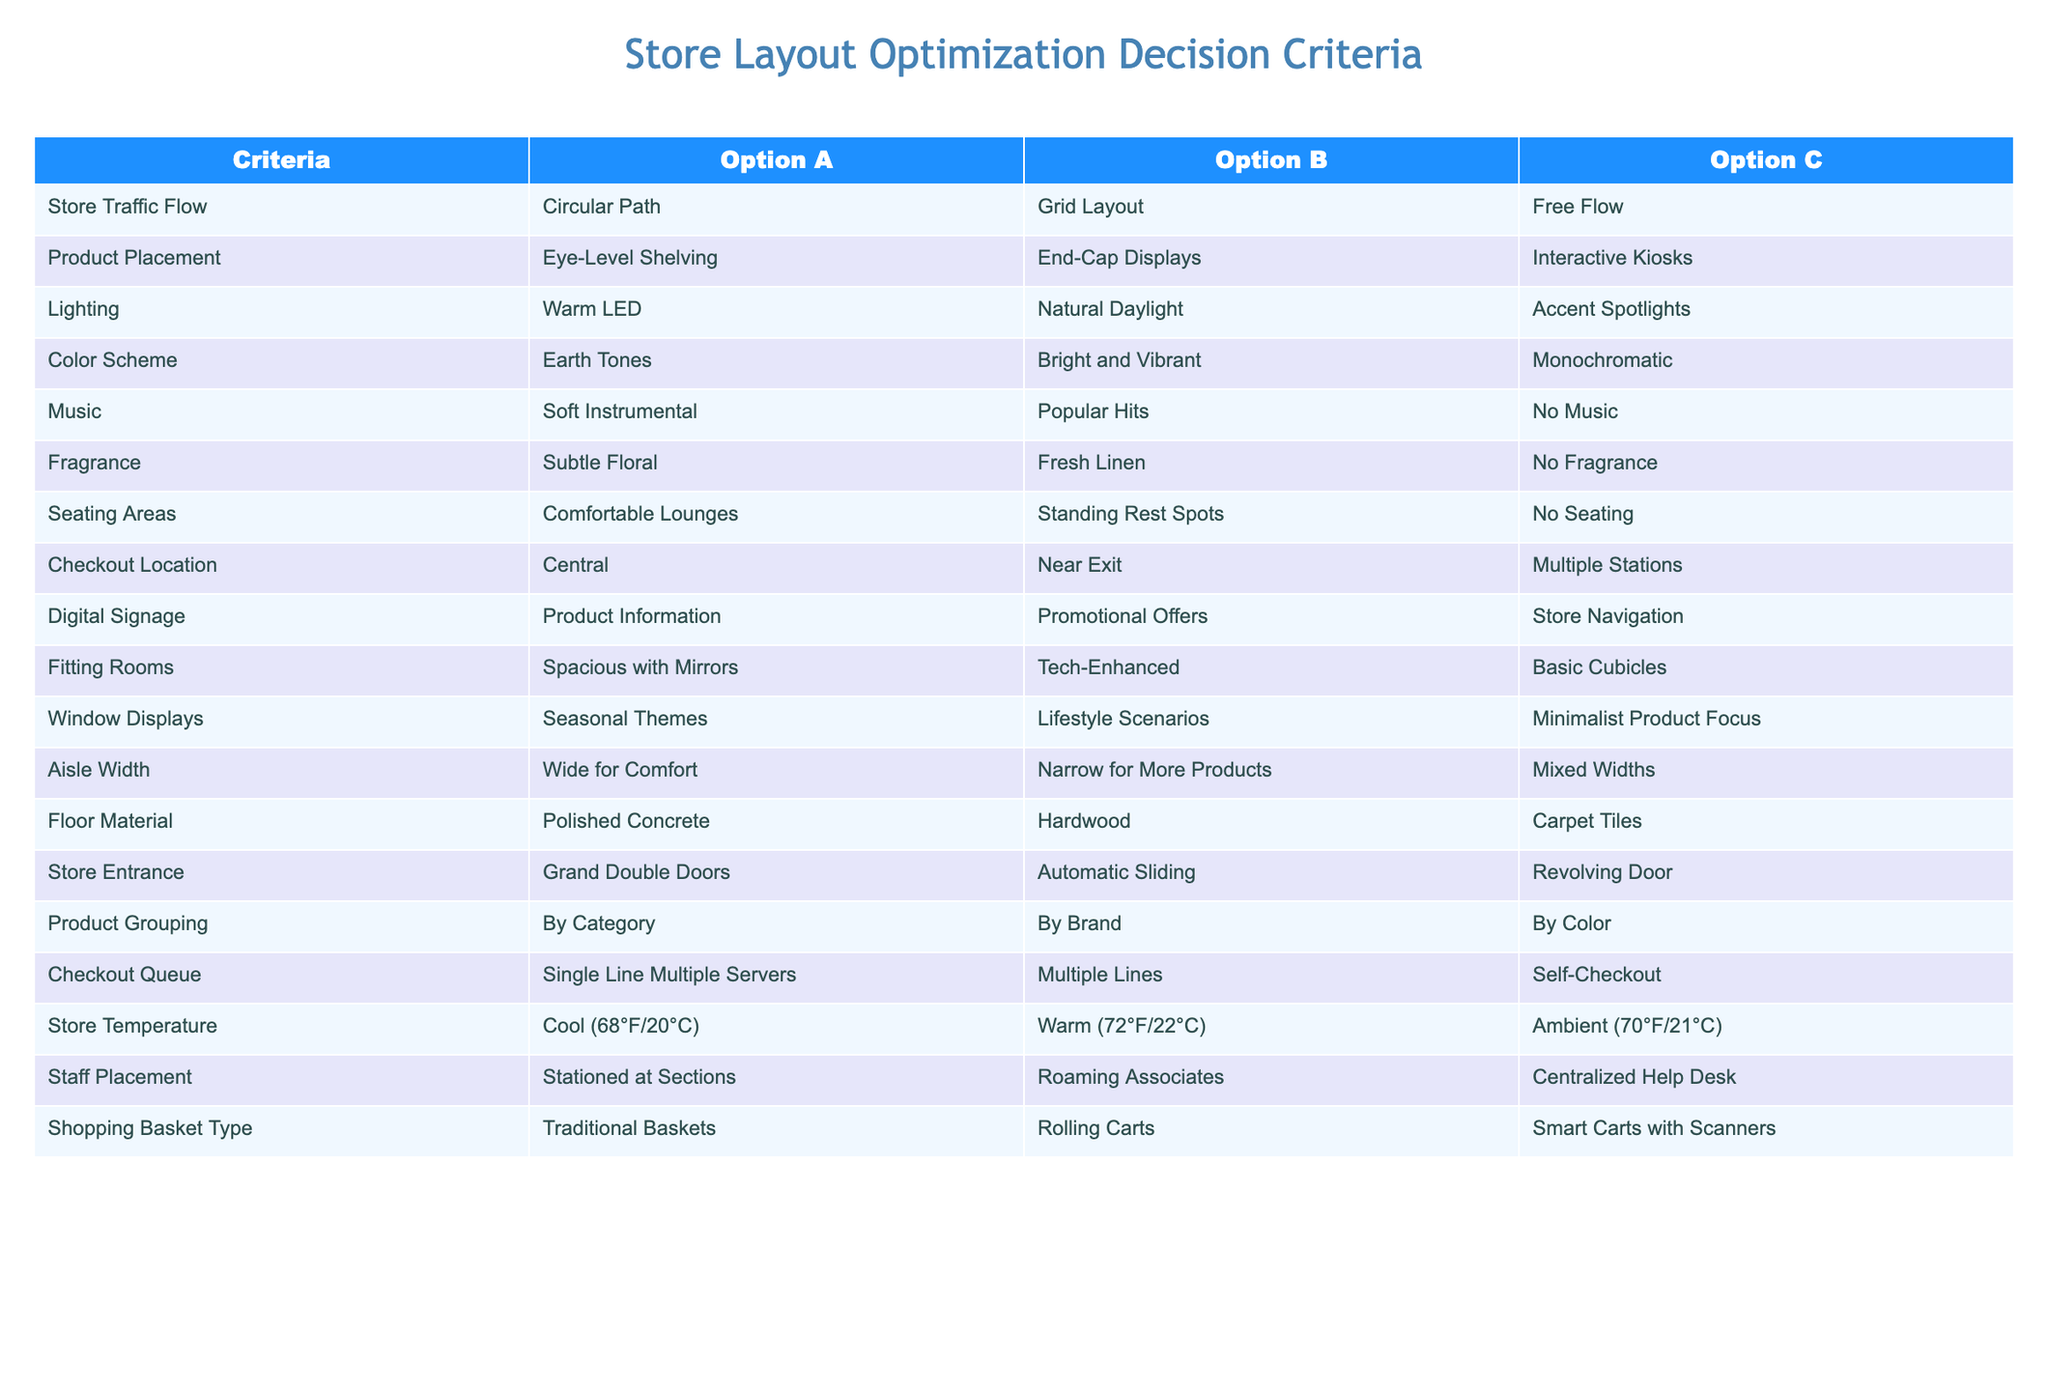What is the product placement option that uses Eye-Level Shelving? According to the table, the option for Product Placement that uses Eye-Level Shelving is Option A.
Answer: Option A Which lighting option is natural? The table indicates that Natural Daylight is the lighting option categorized under Option B.
Answer: Option B Are the checkout locations more centralized or dispersed? The table shows that the centralized checkout location is listed as Option A, while the near exit is Option B and multiple stations is Option C. Thus, the most centralized option is Option A.
Answer: Yes What is the difference between the aisle widths in terms of comfort and product variety? The table lists Wide for Comfort under Option A and Narrow for More Products under Option B. The difference indicates that Wide offers a comfortable shopping experience, while Narrow maximizes product presence.
Answer: Comfort vs. Variety Which seating area option is most comfortable? From the table, Option A represents Comfortable Lounges, which is the most comfortable seating area option compared to the other options.
Answer: Option A How many different color scheme options prioritize brightness? The table has one option that includes Bright and Vibrant colors, which is listed in Option B. Therefore, there is only one option for brightness.
Answer: One Is there a fragrance option that enhances ambiance but is not overpowering? The table shows Subtle Floral under Option A as a fragrance option that enhances ambiance without being overpowering, while Fresh Linen and No Fragrance are different.
Answer: Yes If a store wants to optimize product engagement, which product placement option should they choose? The table indicates that Interactive Kiosks under Option C may optimize product engagement by fostering interaction, as other options focus on shelving layout.
Answer: Option C Which checkout queue option maximizes the server's presence? The table shows that the Single Line Multiple Servers under Option A allows for maximizing server presence by having more associates available for customers.
Answer: Option A 